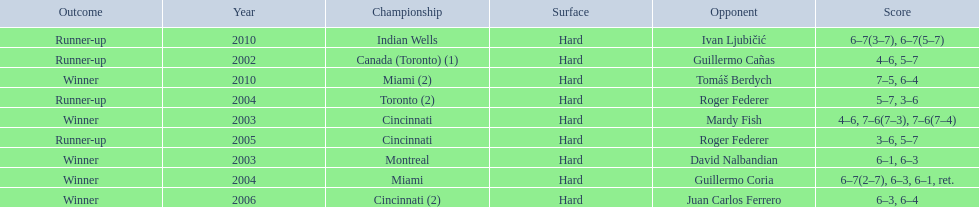How many times was roger federer a runner-up? 2. 